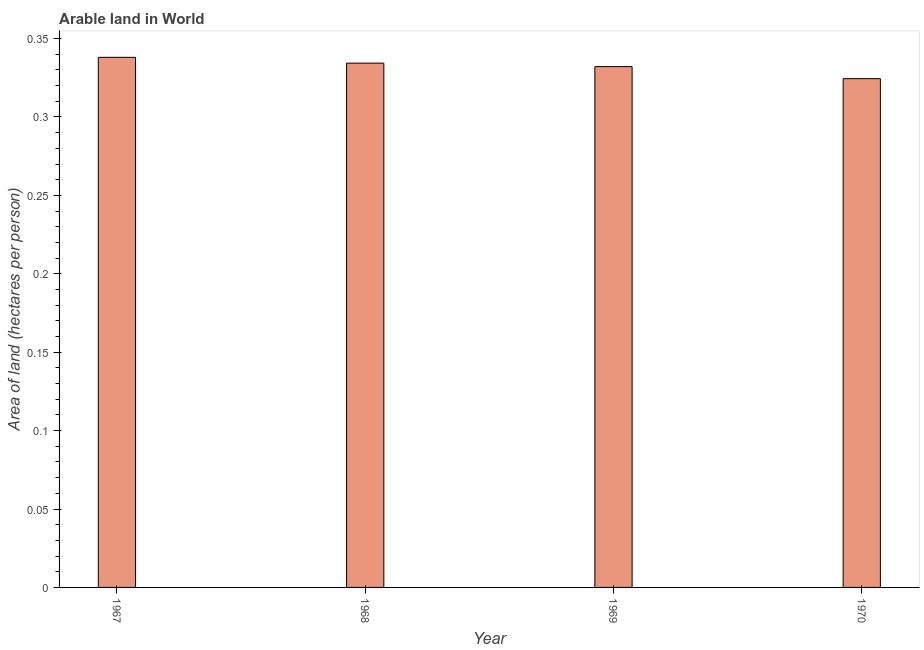Does the graph contain any zero values?
Provide a short and direct response. No. Does the graph contain grids?
Your response must be concise. No. What is the title of the graph?
Keep it short and to the point. Arable land in World. What is the label or title of the Y-axis?
Your answer should be very brief. Area of land (hectares per person). What is the area of arable land in 1969?
Keep it short and to the point. 0.33. Across all years, what is the maximum area of arable land?
Your answer should be compact. 0.34. Across all years, what is the minimum area of arable land?
Your answer should be compact. 0.32. In which year was the area of arable land maximum?
Offer a terse response. 1967. What is the sum of the area of arable land?
Keep it short and to the point. 1.33. What is the difference between the area of arable land in 1967 and 1970?
Give a very brief answer. 0.01. What is the average area of arable land per year?
Make the answer very short. 0.33. What is the median area of arable land?
Provide a succinct answer. 0.33. Do a majority of the years between 1968 and 1969 (inclusive) have area of arable land greater than 0.06 hectares per person?
Keep it short and to the point. Yes. What is the ratio of the area of arable land in 1967 to that in 1969?
Offer a very short reply. 1.02. Is the difference between the area of arable land in 1968 and 1969 greater than the difference between any two years?
Offer a terse response. No. What is the difference between the highest and the second highest area of arable land?
Provide a succinct answer. 0. Is the sum of the area of arable land in 1969 and 1970 greater than the maximum area of arable land across all years?
Offer a very short reply. Yes. What is the difference between the highest and the lowest area of arable land?
Provide a succinct answer. 0.01. How many bars are there?
Make the answer very short. 4. Are all the bars in the graph horizontal?
Ensure brevity in your answer.  No. What is the difference between two consecutive major ticks on the Y-axis?
Make the answer very short. 0.05. Are the values on the major ticks of Y-axis written in scientific E-notation?
Offer a very short reply. No. What is the Area of land (hectares per person) in 1967?
Provide a succinct answer. 0.34. What is the Area of land (hectares per person) of 1968?
Make the answer very short. 0.33. What is the Area of land (hectares per person) in 1969?
Make the answer very short. 0.33. What is the Area of land (hectares per person) of 1970?
Give a very brief answer. 0.32. What is the difference between the Area of land (hectares per person) in 1967 and 1968?
Make the answer very short. 0. What is the difference between the Area of land (hectares per person) in 1967 and 1969?
Give a very brief answer. 0.01. What is the difference between the Area of land (hectares per person) in 1967 and 1970?
Your answer should be very brief. 0.01. What is the difference between the Area of land (hectares per person) in 1968 and 1969?
Ensure brevity in your answer.  0. What is the difference between the Area of land (hectares per person) in 1968 and 1970?
Make the answer very short. 0.01. What is the difference between the Area of land (hectares per person) in 1969 and 1970?
Ensure brevity in your answer.  0.01. What is the ratio of the Area of land (hectares per person) in 1967 to that in 1968?
Offer a terse response. 1.01. What is the ratio of the Area of land (hectares per person) in 1967 to that in 1970?
Give a very brief answer. 1.04. What is the ratio of the Area of land (hectares per person) in 1968 to that in 1969?
Offer a terse response. 1.01. What is the ratio of the Area of land (hectares per person) in 1968 to that in 1970?
Give a very brief answer. 1.03. What is the ratio of the Area of land (hectares per person) in 1969 to that in 1970?
Offer a very short reply. 1.02. 